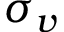<formula> <loc_0><loc_0><loc_500><loc_500>\sigma _ { v }</formula> 